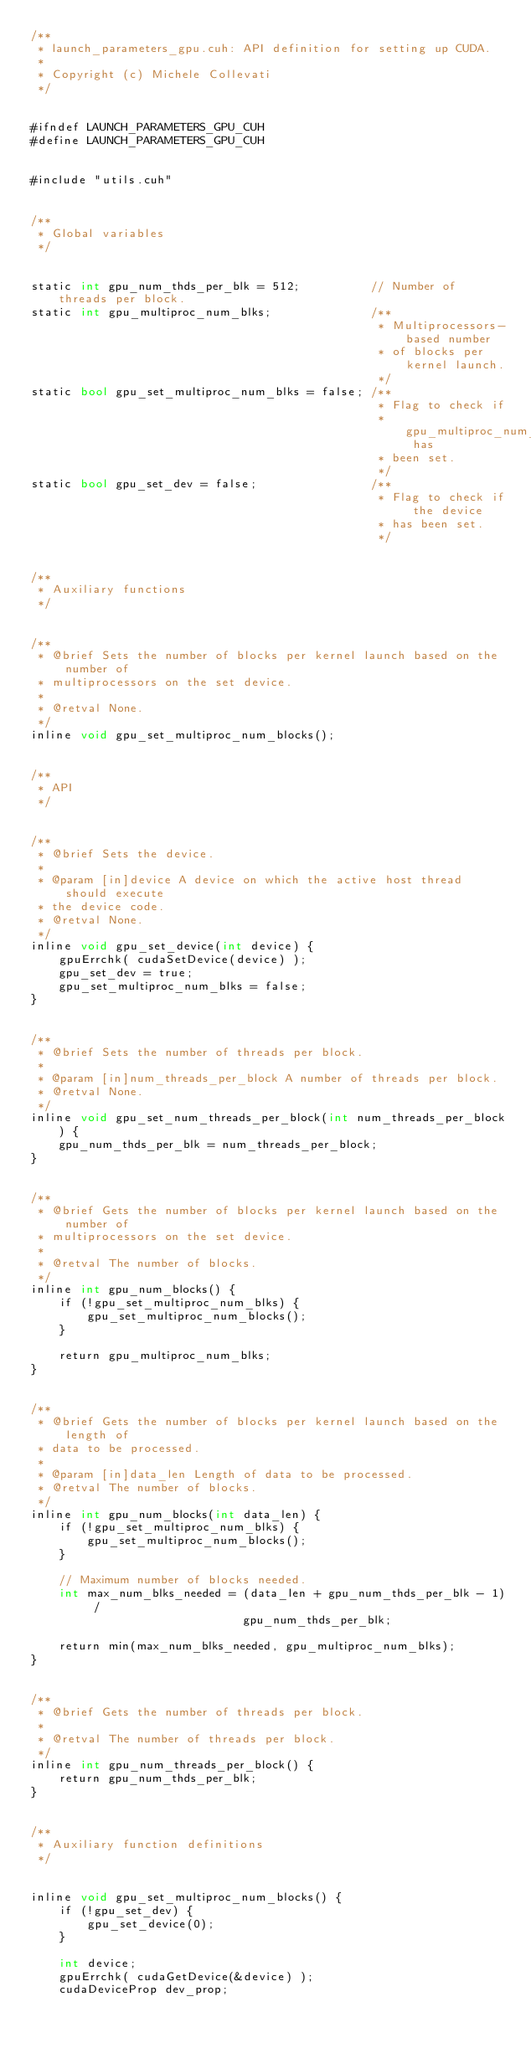Convert code to text. <code><loc_0><loc_0><loc_500><loc_500><_Cuda_>/**
 * launch_parameters_gpu.cuh: API definition for setting up CUDA.
 * 
 * Copyright (c) Michele Collevati
 */


#ifndef LAUNCH_PARAMETERS_GPU_CUH
#define LAUNCH_PARAMETERS_GPU_CUH


#include "utils.cuh"


/**
 * Global variables
 */


static int gpu_num_thds_per_blk = 512;          // Number of threads per block.
static int gpu_multiproc_num_blks;              /**
                                                 * Multiprocessors-based number
                                                 * of blocks per kernel launch.
                                                 */
static bool gpu_set_multiproc_num_blks = false; /**
                                                 * Flag to check if
                                                 * gpu_multiproc_num_blks has
                                                 * been set.
                                                 */
static bool gpu_set_dev = false;                /**
                                                 * Flag to check if the device
                                                 * has been set.
                                                 */


/**
 * Auxiliary functions
 */


/**
 * @brief Sets the number of blocks per kernel launch based on the number of
 * multiprocessors on the set device.
 * 
 * @retval None.
 */
inline void gpu_set_multiproc_num_blocks();


/**
 * API
 */


/**
 * @brief Sets the device.
 * 
 * @param [in]device A device on which the active host thread should execute
 * the device code.
 * @retval None.
 */
inline void gpu_set_device(int device) {
    gpuErrchk( cudaSetDevice(device) );
    gpu_set_dev = true;
    gpu_set_multiproc_num_blks = false;
}


/**
 * @brief Sets the number of threads per block.
 * 
 * @param [in]num_threads_per_block A number of threads per block.
 * @retval None.
 */
inline void gpu_set_num_threads_per_block(int num_threads_per_block) {
    gpu_num_thds_per_blk = num_threads_per_block;
}


/**
 * @brief Gets the number of blocks per kernel launch based on the number of
 * multiprocessors on the set device.
 * 
 * @retval The number of blocks.
 */
inline int gpu_num_blocks() {
    if (!gpu_set_multiproc_num_blks) {
        gpu_set_multiproc_num_blocks();
    }

    return gpu_multiproc_num_blks;
}


/**
 * @brief Gets the number of blocks per kernel launch based on the length of
 * data to be processed.
 * 
 * @param [in]data_len Length of data to be processed.
 * @retval The number of blocks.
 */
inline int gpu_num_blocks(int data_len) {
    if (!gpu_set_multiproc_num_blks) {
        gpu_set_multiproc_num_blocks();
    }

    // Maximum number of blocks needed.
    int max_num_blks_needed = (data_len + gpu_num_thds_per_blk - 1) /
                              gpu_num_thds_per_blk;

    return min(max_num_blks_needed, gpu_multiproc_num_blks);
}


/**
 * @brief Gets the number of threads per block.
 * 
 * @retval The number of threads per block.
 */
inline int gpu_num_threads_per_block() {
    return gpu_num_thds_per_blk;
}


/**
 * Auxiliary function definitions
 */


inline void gpu_set_multiproc_num_blocks() {
    if (!gpu_set_dev) {
        gpu_set_device(0);
    }

    int device;
    gpuErrchk( cudaGetDevice(&device) );
    cudaDeviceProp dev_prop;</code> 